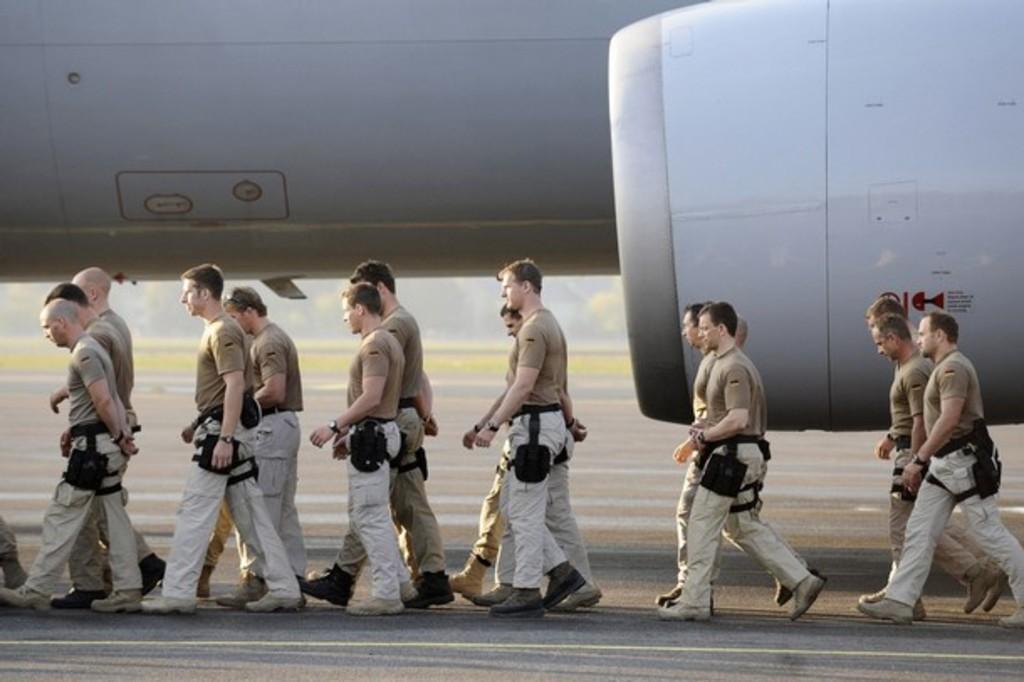Please provide a concise description of this image. In this image I can see few people walking. Back I can see a white color aircraft. 